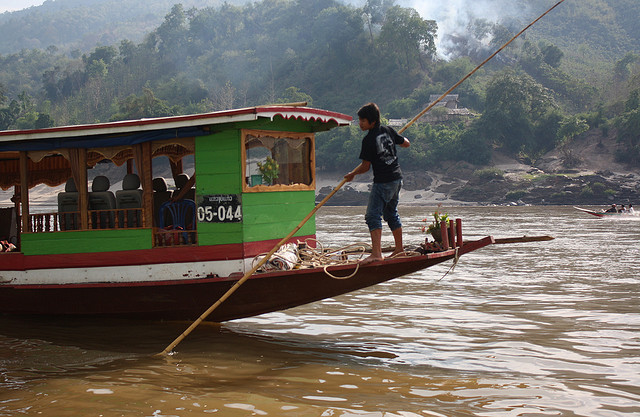Please transcribe the text information in this image. 05 044 